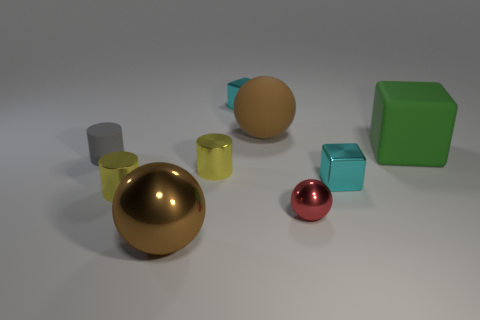What color is the big object left of the shiny thing that is behind the large brown sphere on the right side of the large metallic sphere?
Your answer should be compact. Brown. What size is the metal block on the left side of the matte sphere?
Make the answer very short. Small. How many small things are either shiny balls or gray rubber objects?
Ensure brevity in your answer.  2. What is the color of the ball that is both on the left side of the red metallic sphere and in front of the green rubber thing?
Offer a terse response. Brown. Are there any other big objects that have the same shape as the green thing?
Make the answer very short. No. What material is the small red ball?
Offer a terse response. Metal. There is a small red ball; are there any small metallic cylinders in front of it?
Offer a terse response. No. Is the red metallic object the same shape as the tiny gray rubber thing?
Your response must be concise. No. How many other objects are there of the same size as the gray cylinder?
Your response must be concise. 5. How many things are big matte things that are to the left of the small red shiny ball or small yellow objects?
Offer a terse response. 3. 